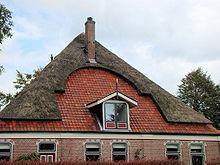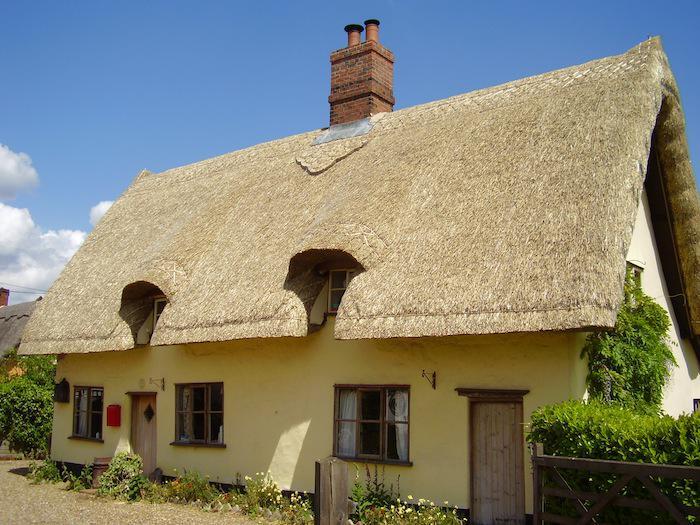The first image is the image on the left, the second image is the image on the right. Evaluate the accuracy of this statement regarding the images: "In at least one image there is a white house with black angle strips on it.". Is it true? Answer yes or no. No. The first image is the image on the left, the second image is the image on the right. Analyze the images presented: Is the assertion "A building facing leftward has a long thatched roof with two notches on the bottom made to accommodate a door or window." valid? Answer yes or no. Yes. 